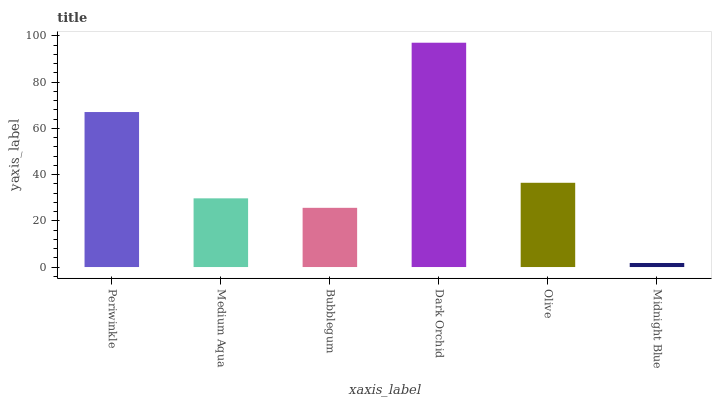Is Midnight Blue the minimum?
Answer yes or no. Yes. Is Dark Orchid the maximum?
Answer yes or no. Yes. Is Medium Aqua the minimum?
Answer yes or no. No. Is Medium Aqua the maximum?
Answer yes or no. No. Is Periwinkle greater than Medium Aqua?
Answer yes or no. Yes. Is Medium Aqua less than Periwinkle?
Answer yes or no. Yes. Is Medium Aqua greater than Periwinkle?
Answer yes or no. No. Is Periwinkle less than Medium Aqua?
Answer yes or no. No. Is Olive the high median?
Answer yes or no. Yes. Is Medium Aqua the low median?
Answer yes or no. Yes. Is Bubblegum the high median?
Answer yes or no. No. Is Periwinkle the low median?
Answer yes or no. No. 